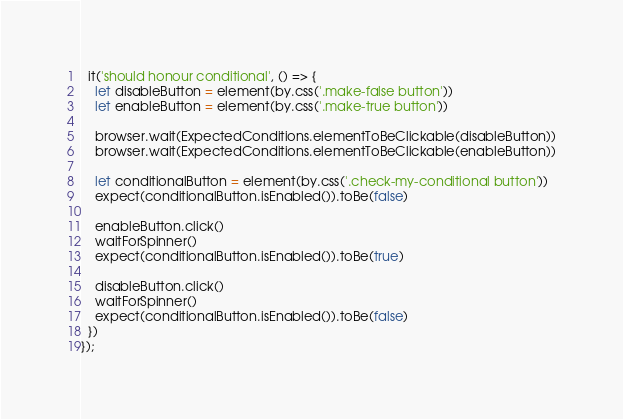<code> <loc_0><loc_0><loc_500><loc_500><_TypeScript_>
  it('should honour conditional', () => {
    let disableButton = element(by.css('.make-false button'))
    let enableButton = element(by.css('.make-true button'))

    browser.wait(ExpectedConditions.elementToBeClickable(disableButton))
    browser.wait(ExpectedConditions.elementToBeClickable(enableButton))

    let conditionalButton = element(by.css('.check-my-conditional button'))
    expect(conditionalButton.isEnabled()).toBe(false)

    enableButton.click()
    waitForSpinner()
    expect(conditionalButton.isEnabled()).toBe(true)

    disableButton.click()
    waitForSpinner()
    expect(conditionalButton.isEnabled()).toBe(false)
  })
});</code> 